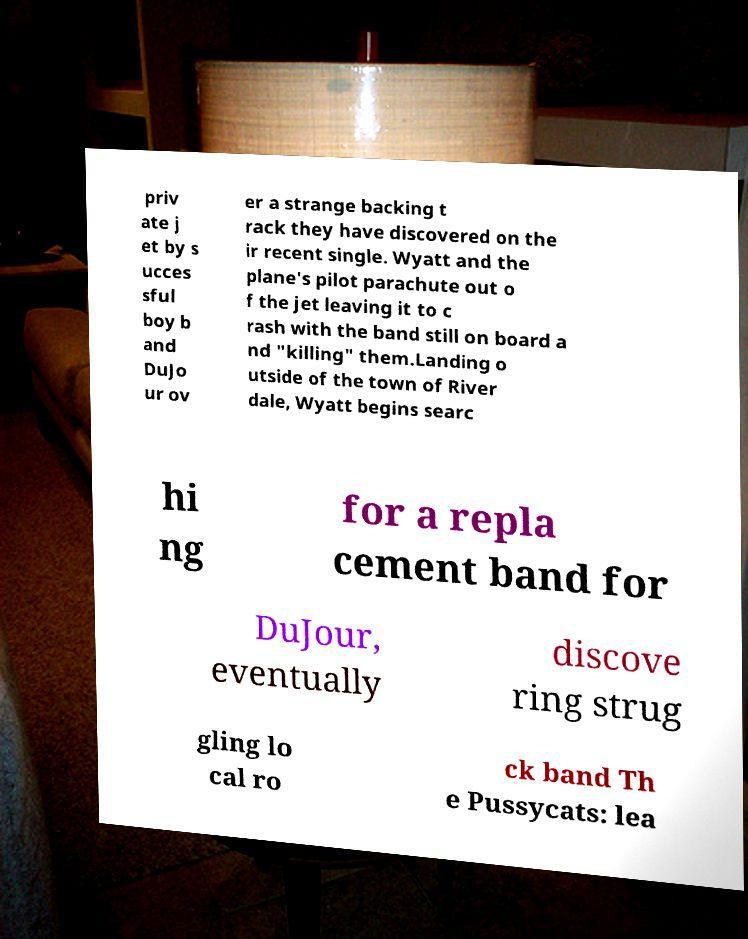Can you accurately transcribe the text from the provided image for me? priv ate j et by s ucces sful boy b and DuJo ur ov er a strange backing t rack they have discovered on the ir recent single. Wyatt and the plane's pilot parachute out o f the jet leaving it to c rash with the band still on board a nd "killing" them.Landing o utside of the town of River dale, Wyatt begins searc hi ng for a repla cement band for DuJour, eventually discove ring strug gling lo cal ro ck band Th e Pussycats: lea 